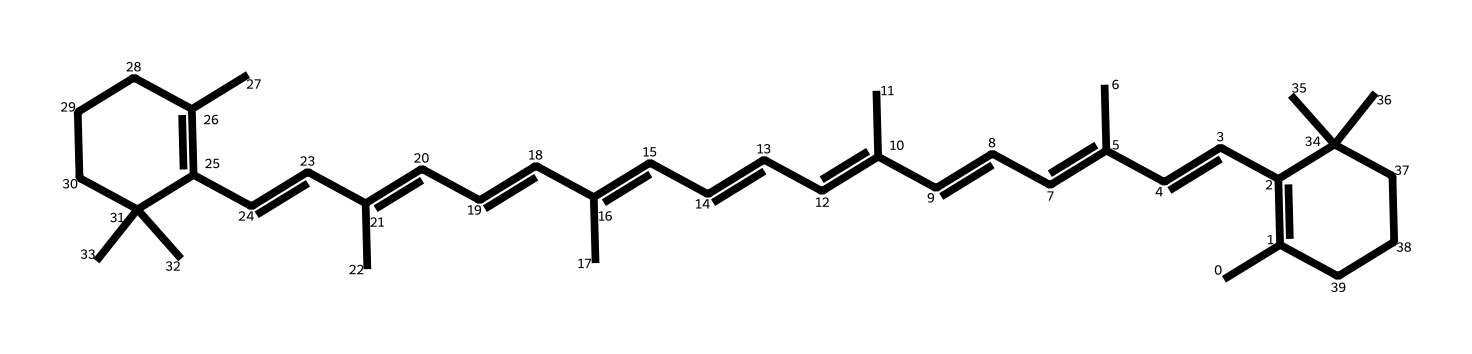what is the molecular formula of beta-carotene? By analyzing the structure represented in the SMILES notation, we can count the number of carbon (C) and hydrogen (H) atoms. The structure shows a total of 40 carbon atoms and 56 hydrogen atoms, which leads to the molecular formula C40H56.
Answer: C40H56 how many double bonds are present in beta-carotene? The chemical structure reveals multiple conjugated double bonds along the carbon chain. By examining the structure closely, we can identify that there are 11 double bonds located throughout the molecule.
Answer: 11 what type of isomerism is exhibited by beta-carotene? The structure of beta-carotene indicates that it contains multiple double bonds, which allows for the existence of geometric isomers (cis/trans). The presence of these multiple double bonds confirms that beta-carotene exhibits geometric isomerism.
Answer: geometric isomerism is beta-carotene a solid or liquid at room temperature? Given the long hydrocarbon chains and the overall structure of beta-carotene, it is a large organic molecule that is generally solid at room temperature due to its non-polar nature and crystalline arrangement.
Answer: solid how does the structure of beta-carotene contribute to its function in plants? Beta-carotene has a structure that allows it to efficiently absorb light energy due to its conjugated double bonds. This structural feature enables it to play an important role in photosynthesis as a pigment, capturing light energy for the plant.
Answer: captures light energy does beta-carotene dissolve in water? As a non-polar molecule with a hydrocarbon backbone, beta-carotene does not dissolve well in polar solvents like water due to the difference in polarity. Its solubility is more compatible with non-polar solvents.
Answer: no 